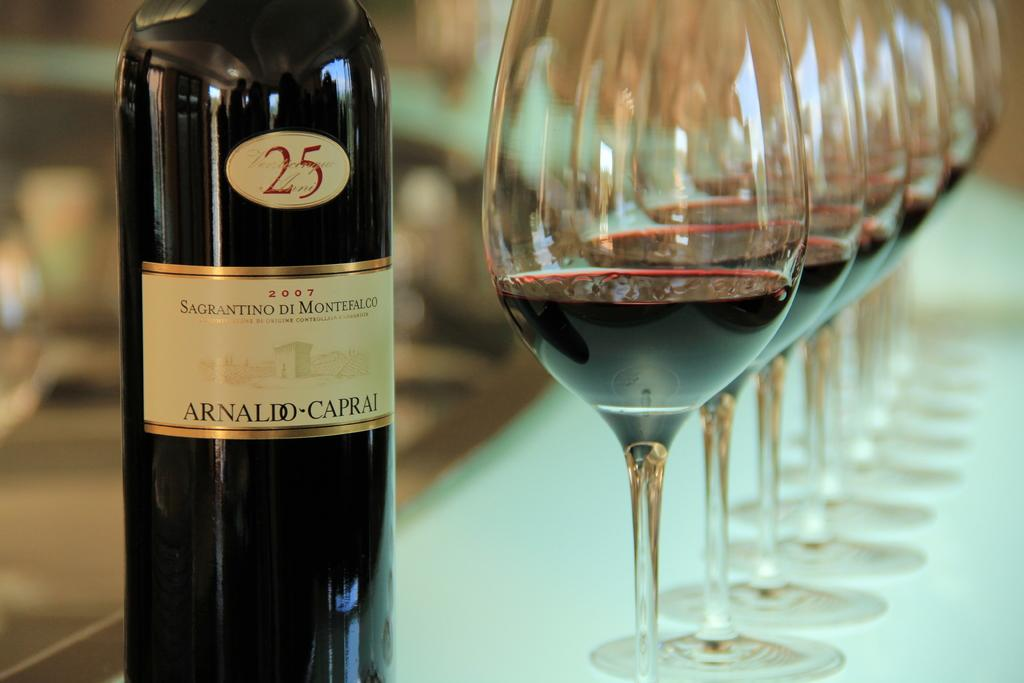<image>
Relay a brief, clear account of the picture shown. Bottle of wine with a white label that has a number 25 on it. 